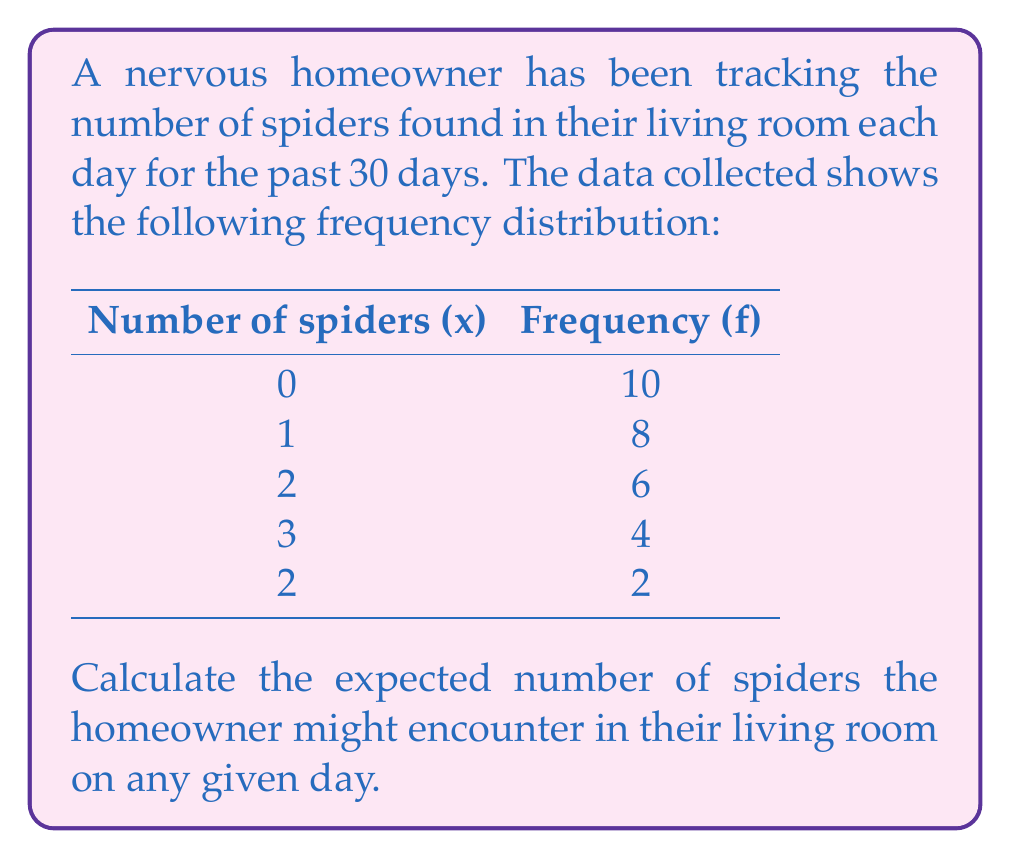Show me your answer to this math problem. To find the expected number of spiders, we need to calculate the expected value (E(X)) of the random variable X, which represents the number of spiders.

Step 1: Calculate the total number of observations (n).
$$n = 10 + 8 + 6 + 4 + 2 = 30$$

Step 2: Calculate the probability of each outcome.
$$P(X = 0) = \frac{10}{30} = \frac{1}{3}$$
$$P(X = 1) = \frac{8}{30} = \frac{4}{15}$$
$$P(X = 2) = \frac{6}{30} = \frac{1}{5}$$
$$P(X = 3) = \frac{4}{30} = \frac{2}{15}$$
$$P(X = 4) = \frac{2}{30} = \frac{1}{15}$$

Step 3: Calculate the expected value using the formula:
$$E(X) = \sum_{i=1}^{n} x_i \cdot P(X = x_i)$$

$$E(X) = 0 \cdot \frac{1}{3} + 1 \cdot \frac{4}{15} + 2 \cdot \frac{1}{5} + 3 \cdot \frac{2}{15} + 4 \cdot \frac{1}{15}$$

$$E(X) = 0 + \frac{4}{15} + \frac{2}{5} + \frac{6}{15} + \frac{4}{15}$$

$$E(X) = \frac{4 + 6 + 6 + 4}{15} = \frac{20}{15} = \frac{4}{3}$$

Therefore, the expected number of spiders the homeowner might encounter in their living room on any given day is $\frac{4}{3}$ or approximately 1.33 spiders.
Answer: $\frac{4}{3}$ spiders 